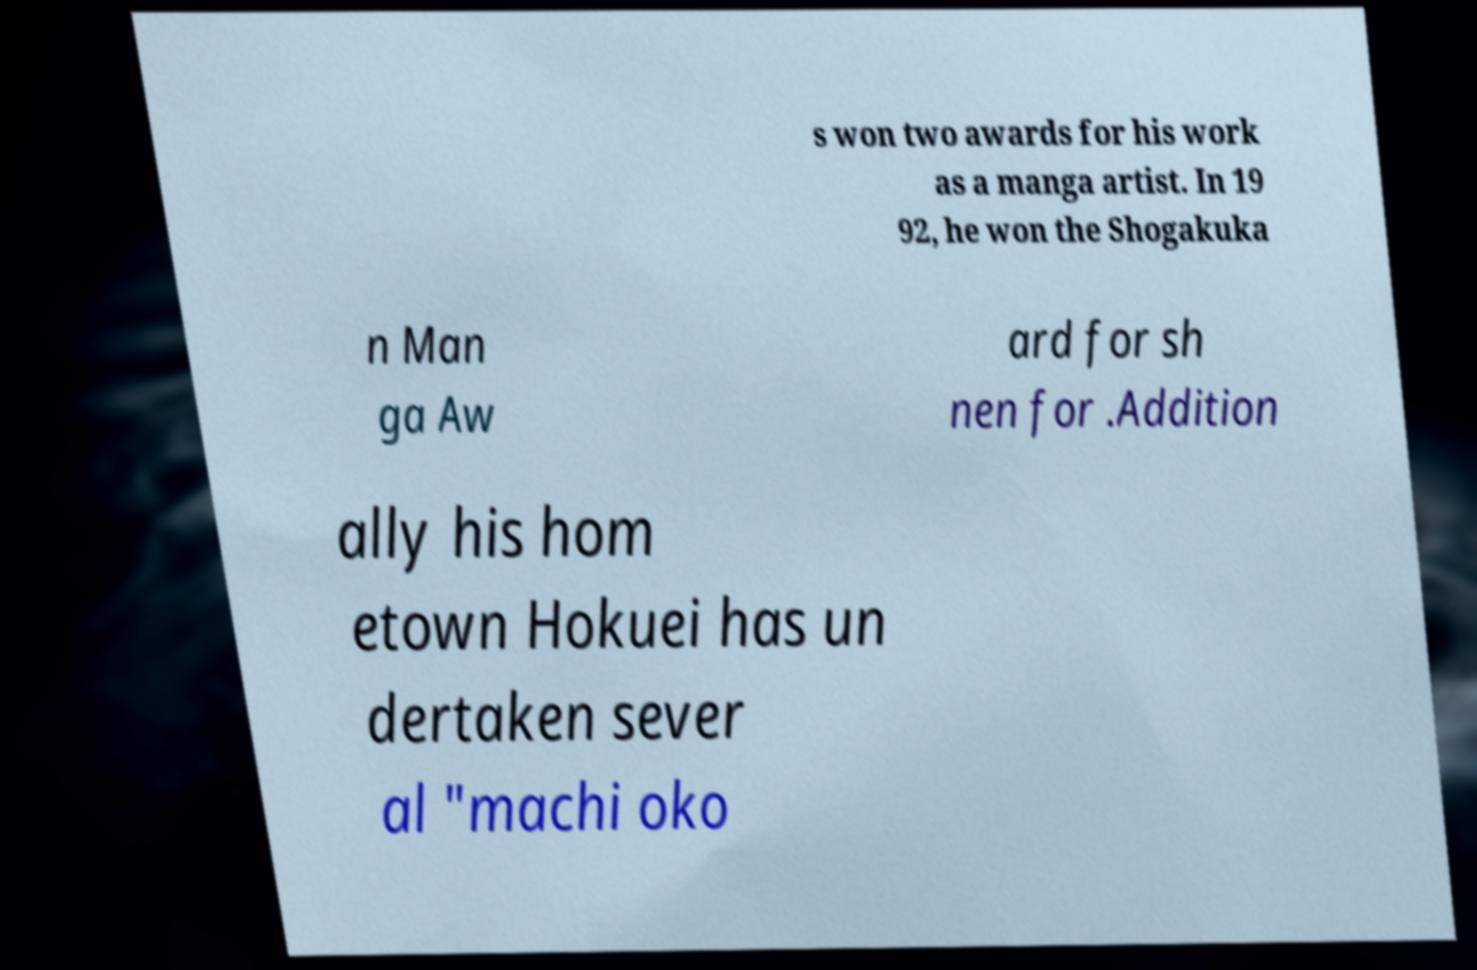Please identify and transcribe the text found in this image. s won two awards for his work as a manga artist. In 19 92, he won the Shogakuka n Man ga Aw ard for sh nen for .Addition ally his hom etown Hokuei has un dertaken sever al "machi oko 